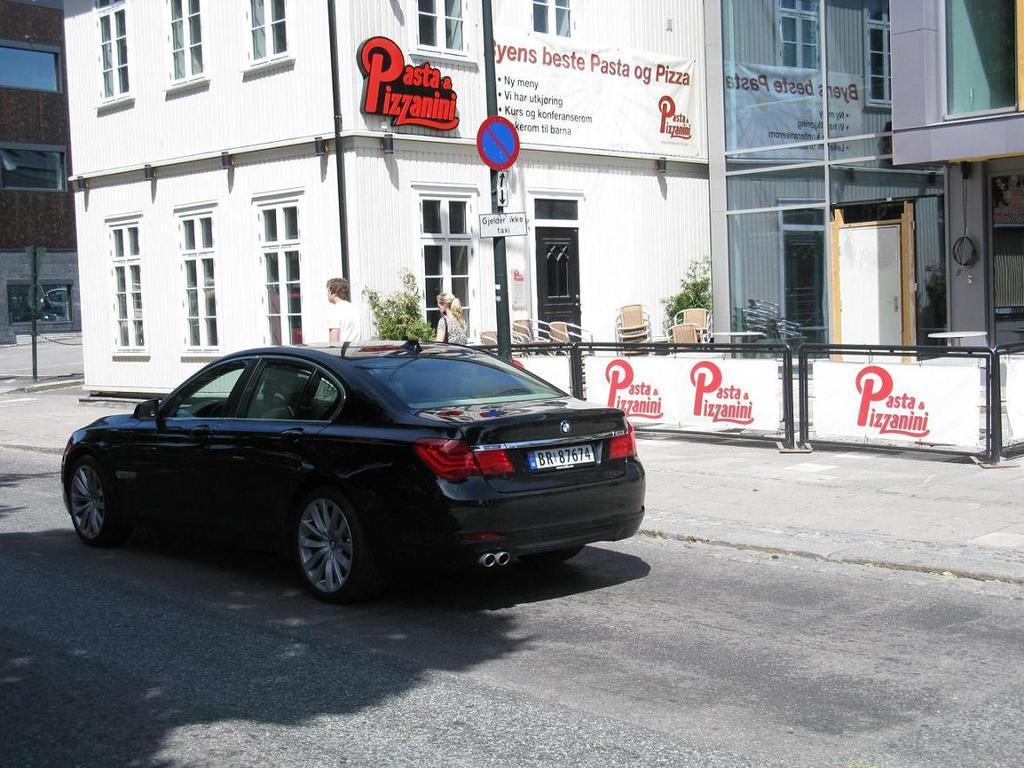What is the main subject of the image? The main subject of the image is a car. What else can be seen in the image besides the car? There are people walking on a pathway, hoardings, sign boards, poles, and buildings in the image. Can you describe the people in the image? The people in the image are walking on a pathway. What type of structures are present in the image? There are sign boards and buildings in the image. How far can the swing be seen in the image? There is no swing present in the image. What causes the person to fall in the image? There is no person falling in the image. 